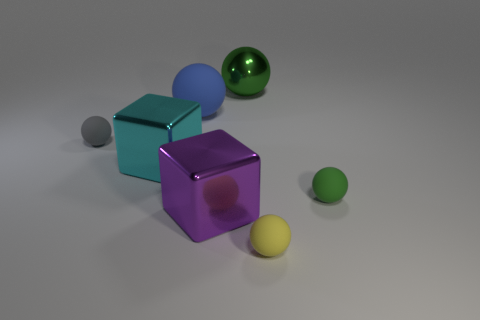How does the lighting in the image affect the appearance of the objects? The lighting in the image is soft and diffused, casting gentle shadows and highlighting the textures and colors of the objects. It gives the scene a realistic dimension by creating depth and revealing the matte or shiny surfaces of the objects. 